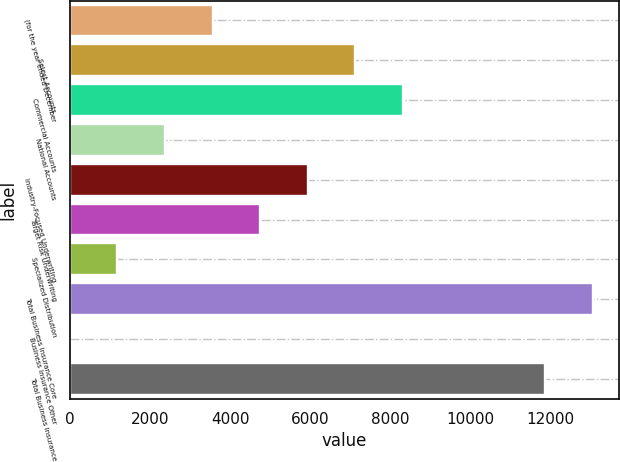<chart> <loc_0><loc_0><loc_500><loc_500><bar_chart><fcel>(for the year ended December<fcel>Select Accounts<fcel>Commercial Accounts<fcel>National Accounts<fcel>Industry-Focused Underwriting<fcel>Target Risk Underwriting<fcel>Specialized Distribution<fcel>Total Business Insurance Core<fcel>Business Insurance Other<fcel>Total Business Insurance<nl><fcel>3562.6<fcel>7124.2<fcel>8311.4<fcel>2375.4<fcel>5937<fcel>4749.8<fcel>1188.2<fcel>13059.2<fcel>1<fcel>11872<nl></chart> 